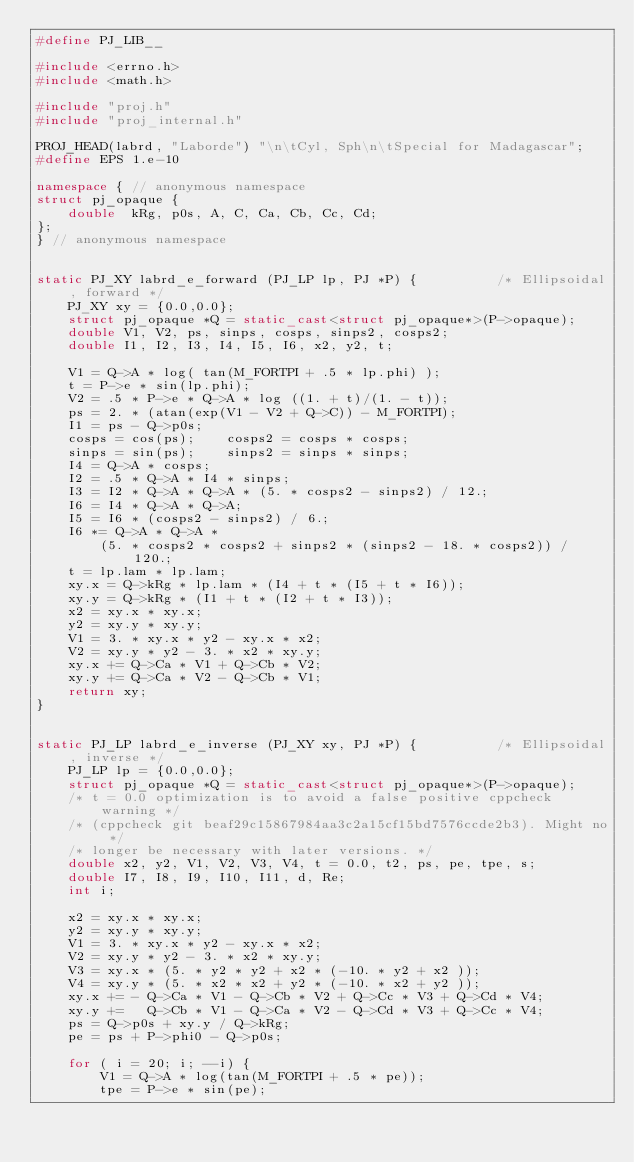<code> <loc_0><loc_0><loc_500><loc_500><_C++_>#define PJ_LIB__

#include <errno.h>
#include <math.h>

#include "proj.h"
#include "proj_internal.h"

PROJ_HEAD(labrd, "Laborde") "\n\tCyl, Sph\n\tSpecial for Madagascar";
#define EPS 1.e-10

namespace { // anonymous namespace
struct pj_opaque {
    double  kRg, p0s, A, C, Ca, Cb, Cc, Cd;
};
} // anonymous namespace


static PJ_XY labrd_e_forward (PJ_LP lp, PJ *P) {          /* Ellipsoidal, forward */
    PJ_XY xy = {0.0,0.0};
    struct pj_opaque *Q = static_cast<struct pj_opaque*>(P->opaque);
    double V1, V2, ps, sinps, cosps, sinps2, cosps2;
    double I1, I2, I3, I4, I5, I6, x2, y2, t;

    V1 = Q->A * log( tan(M_FORTPI + .5 * lp.phi) );
    t = P->e * sin(lp.phi);
    V2 = .5 * P->e * Q->A * log ((1. + t)/(1. - t));
    ps = 2. * (atan(exp(V1 - V2 + Q->C)) - M_FORTPI);
    I1 = ps - Q->p0s;
    cosps = cos(ps);    cosps2 = cosps * cosps;
    sinps = sin(ps);    sinps2 = sinps * sinps;
    I4 = Q->A * cosps;
    I2 = .5 * Q->A * I4 * sinps;
    I3 = I2 * Q->A * Q->A * (5. * cosps2 - sinps2) / 12.;
    I6 = I4 * Q->A * Q->A;
    I5 = I6 * (cosps2 - sinps2) / 6.;
    I6 *= Q->A * Q->A *
        (5. * cosps2 * cosps2 + sinps2 * (sinps2 - 18. * cosps2)) / 120.;
    t = lp.lam * lp.lam;
    xy.x = Q->kRg * lp.lam * (I4 + t * (I5 + t * I6));
    xy.y = Q->kRg * (I1 + t * (I2 + t * I3));
    x2 = xy.x * xy.x;
    y2 = xy.y * xy.y;
    V1 = 3. * xy.x * y2 - xy.x * x2;
    V2 = xy.y * y2 - 3. * x2 * xy.y;
    xy.x += Q->Ca * V1 + Q->Cb * V2;
    xy.y += Q->Ca * V2 - Q->Cb * V1;
    return xy;
}


static PJ_LP labrd_e_inverse (PJ_XY xy, PJ *P) {          /* Ellipsoidal, inverse */
    PJ_LP lp = {0.0,0.0};
    struct pj_opaque *Q = static_cast<struct pj_opaque*>(P->opaque);
    /* t = 0.0 optimization is to avoid a false positive cppcheck warning */
    /* (cppcheck git beaf29c15867984aa3c2a15cf15bd7576ccde2b3). Might no */
    /* longer be necessary with later versions. */
    double x2, y2, V1, V2, V3, V4, t = 0.0, t2, ps, pe, tpe, s;
    double I7, I8, I9, I10, I11, d, Re;
    int i;

    x2 = xy.x * xy.x;
    y2 = xy.y * xy.y;
    V1 = 3. * xy.x * y2 - xy.x * x2;
    V2 = xy.y * y2 - 3. * x2 * xy.y;
    V3 = xy.x * (5. * y2 * y2 + x2 * (-10. * y2 + x2 ));
    V4 = xy.y * (5. * x2 * x2 + y2 * (-10. * x2 + y2 ));
    xy.x += - Q->Ca * V1 - Q->Cb * V2 + Q->Cc * V3 + Q->Cd * V4;
    xy.y +=   Q->Cb * V1 - Q->Ca * V2 - Q->Cd * V3 + Q->Cc * V4;
    ps = Q->p0s + xy.y / Q->kRg;
    pe = ps + P->phi0 - Q->p0s;

    for ( i = 20; i; --i) {
        V1 = Q->A * log(tan(M_FORTPI + .5 * pe));
        tpe = P->e * sin(pe);</code> 